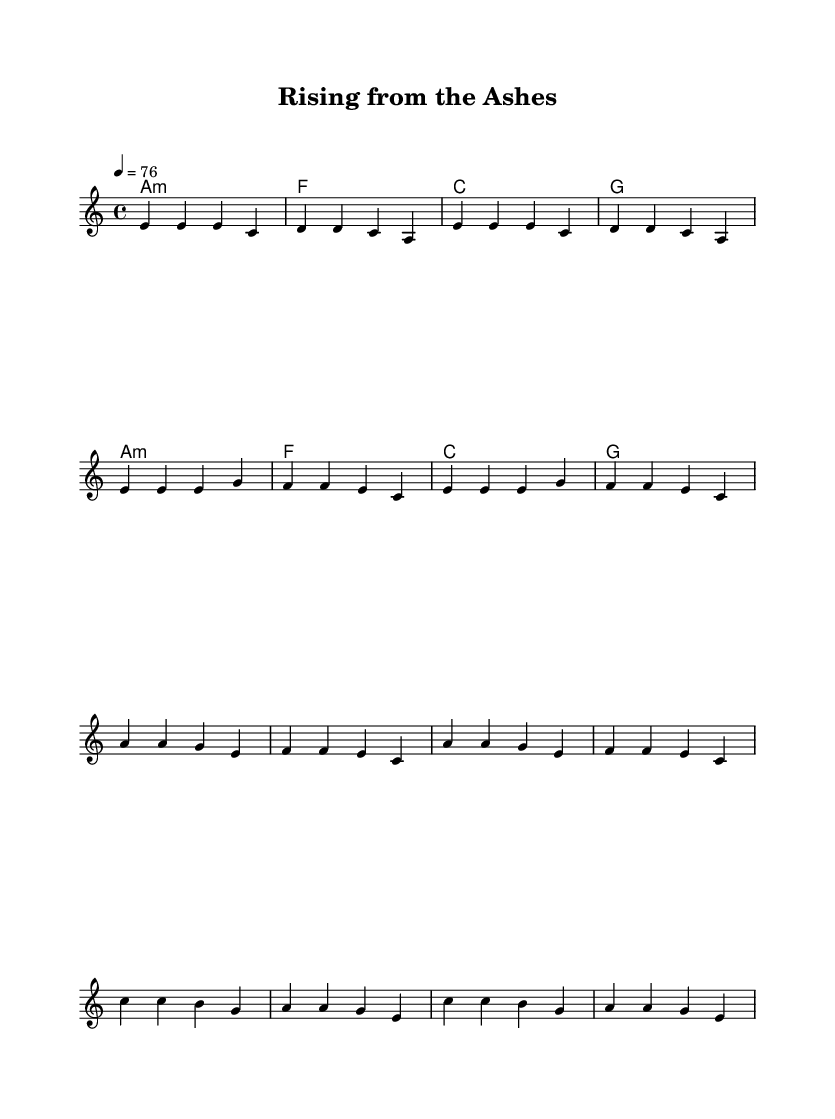What is the key signature of this music? The key signature is indicated as 'a', which means it is in A minor. A minor has no sharps or flats in its key signature.
Answer: A minor What is the time signature of this music? The time signature is indicated as '4/4', meaning there are 4 beats in a measure and the quarter note gets one beat.
Answer: 4/4 What is the tempo marking of the music? The tempo is set at 76 beats per minute as indicated by '4 = 76', which tells us how fast the music should be played.
Answer: 76 How many measures are in the verse of the song? By counting the bars in the melody section for the verse, we find a total of 8 measures.
Answer: 8 Which chord is played at the beginning of the piece? The first chord marked is 'a1:m', indicating that the piece begins with an A minor chord.
Answer: A minor What theme do the lyrics of the chorus express? The lyrics of the chorus express themes of resilience and new beginnings, particularly 'rising from the ashes of a troubled past.'
Answer: Resilience What is the structure of the song? The song consists of verses followed by a chorus, which is a common structure, where the verse presents the narrative and the chorus delivers the main message.
Answer: Verse-Chorus 